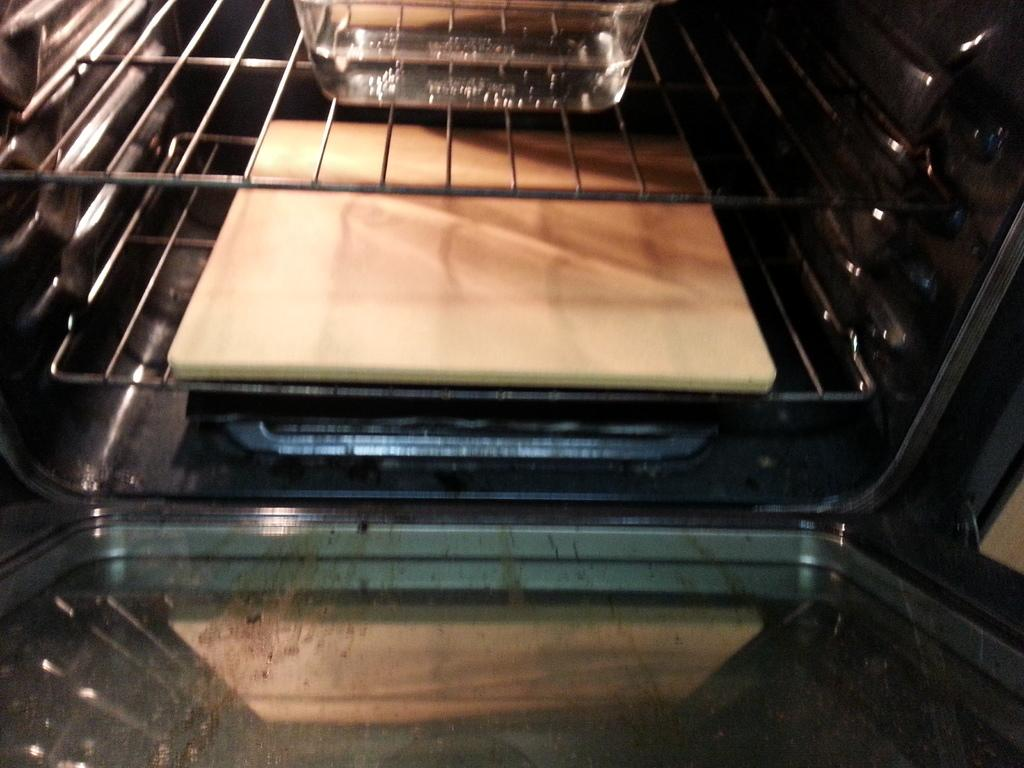What is inside the box in the image? There are trays in the box. What can be found on one of the trays? There is a white color plate on one of the trays. What else is on one of the trays? There is a glass bowl on one of the trays. What type of creature can be seen playing in the garden in the image? There is no creature or garden present in the image; it only shows trays with a white color plate and a glass bowl. 